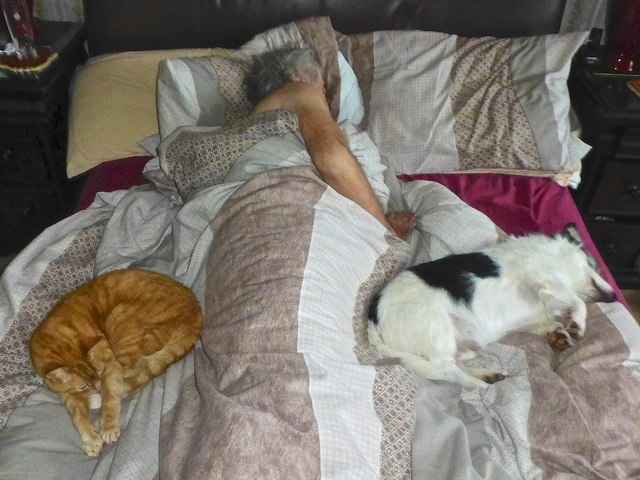Describe the objects in this image and their specific colors. I can see bed in darkgray, gray, black, and lightgray tones, dog in black, lightgray, and darkgray tones, cat in black, maroon, and olive tones, and people in black, gray, and maroon tones in this image. 